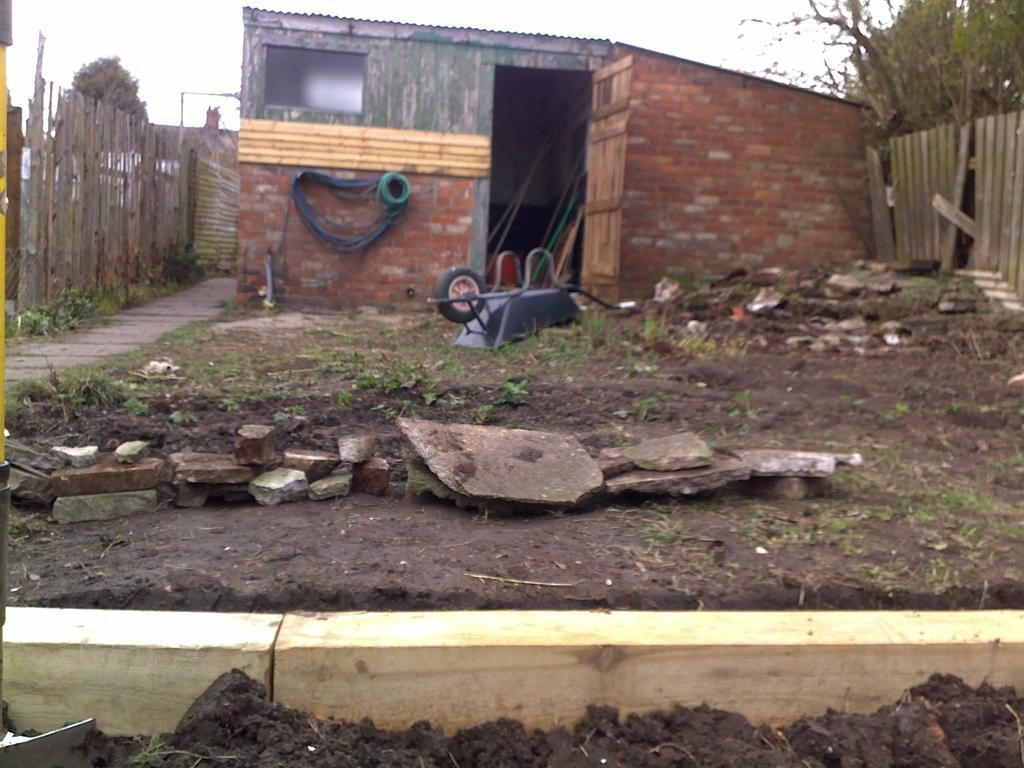What type of structure is present in the image? There is a house in the image. What part of the house can be seen in the image? There is a door in the image. What material is used for the walls of the house? The house has brick walls. What type of fencing is present in the image? There are wooden fences in the image. What type of vegetation is present in the image? There are plants in the image. What type of ground surface is visible in the image? There are stones and grass in the image. What type of pathway is present in the image? There is a walkway in the image. What objects are present in the image? There are objects in the image. What is visible at the top of the image? The sky is visible at the top of the image, and there are trees visible as well. What type of wound can be seen on the back of the house in the image? There is no wound visible on the house in the image, as it is made of brick walls and does not have a backside. 